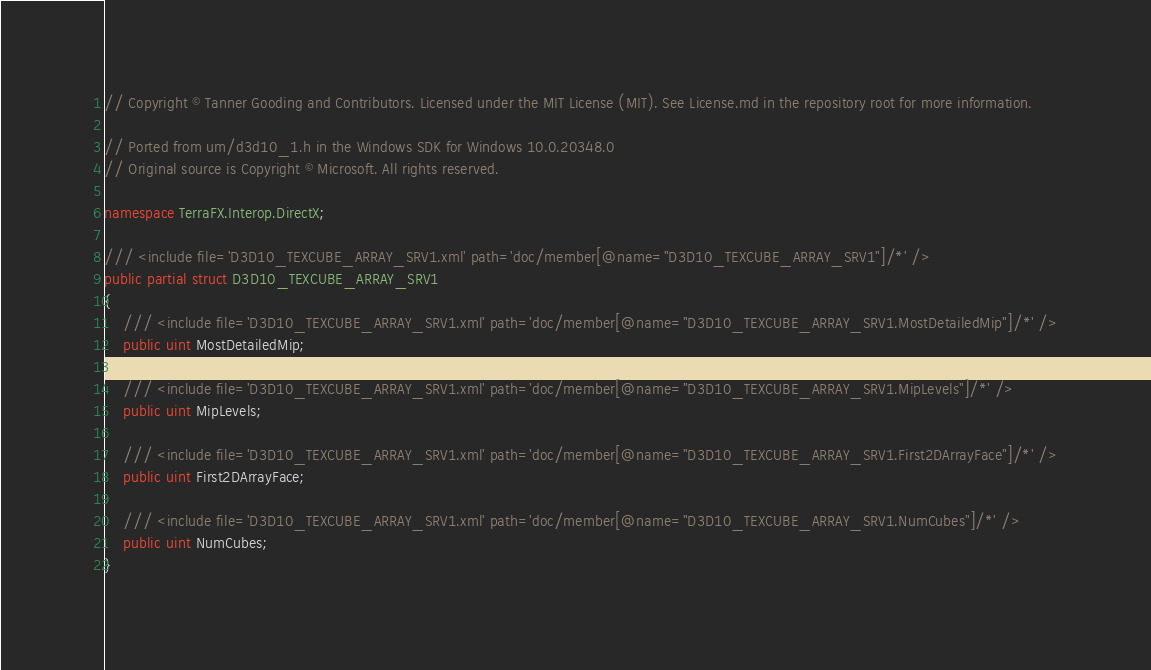<code> <loc_0><loc_0><loc_500><loc_500><_C#_>// Copyright © Tanner Gooding and Contributors. Licensed under the MIT License (MIT). See License.md in the repository root for more information.

// Ported from um/d3d10_1.h in the Windows SDK for Windows 10.0.20348.0
// Original source is Copyright © Microsoft. All rights reserved.

namespace TerraFX.Interop.DirectX;

/// <include file='D3D10_TEXCUBE_ARRAY_SRV1.xml' path='doc/member[@name="D3D10_TEXCUBE_ARRAY_SRV1"]/*' />
public partial struct D3D10_TEXCUBE_ARRAY_SRV1
{
    /// <include file='D3D10_TEXCUBE_ARRAY_SRV1.xml' path='doc/member[@name="D3D10_TEXCUBE_ARRAY_SRV1.MostDetailedMip"]/*' />
    public uint MostDetailedMip;

    /// <include file='D3D10_TEXCUBE_ARRAY_SRV1.xml' path='doc/member[@name="D3D10_TEXCUBE_ARRAY_SRV1.MipLevels"]/*' />
    public uint MipLevels;

    /// <include file='D3D10_TEXCUBE_ARRAY_SRV1.xml' path='doc/member[@name="D3D10_TEXCUBE_ARRAY_SRV1.First2DArrayFace"]/*' />
    public uint First2DArrayFace;

    /// <include file='D3D10_TEXCUBE_ARRAY_SRV1.xml' path='doc/member[@name="D3D10_TEXCUBE_ARRAY_SRV1.NumCubes"]/*' />
    public uint NumCubes;
}
</code> 